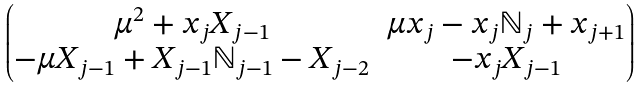Convert formula to latex. <formula><loc_0><loc_0><loc_500><loc_500>\begin{pmatrix} \mu ^ { 2 } + x _ { j } X _ { j - 1 } & \mu x _ { j } - x _ { j } { \mathbb { N } } _ { j } + x _ { j + 1 } \\ - \mu X _ { j - 1 } + X _ { j - 1 } { \mathbb { N } } _ { j - 1 } - X _ { j - 2 } & - x _ { j } X _ { j - 1 } \end{pmatrix}</formula> 